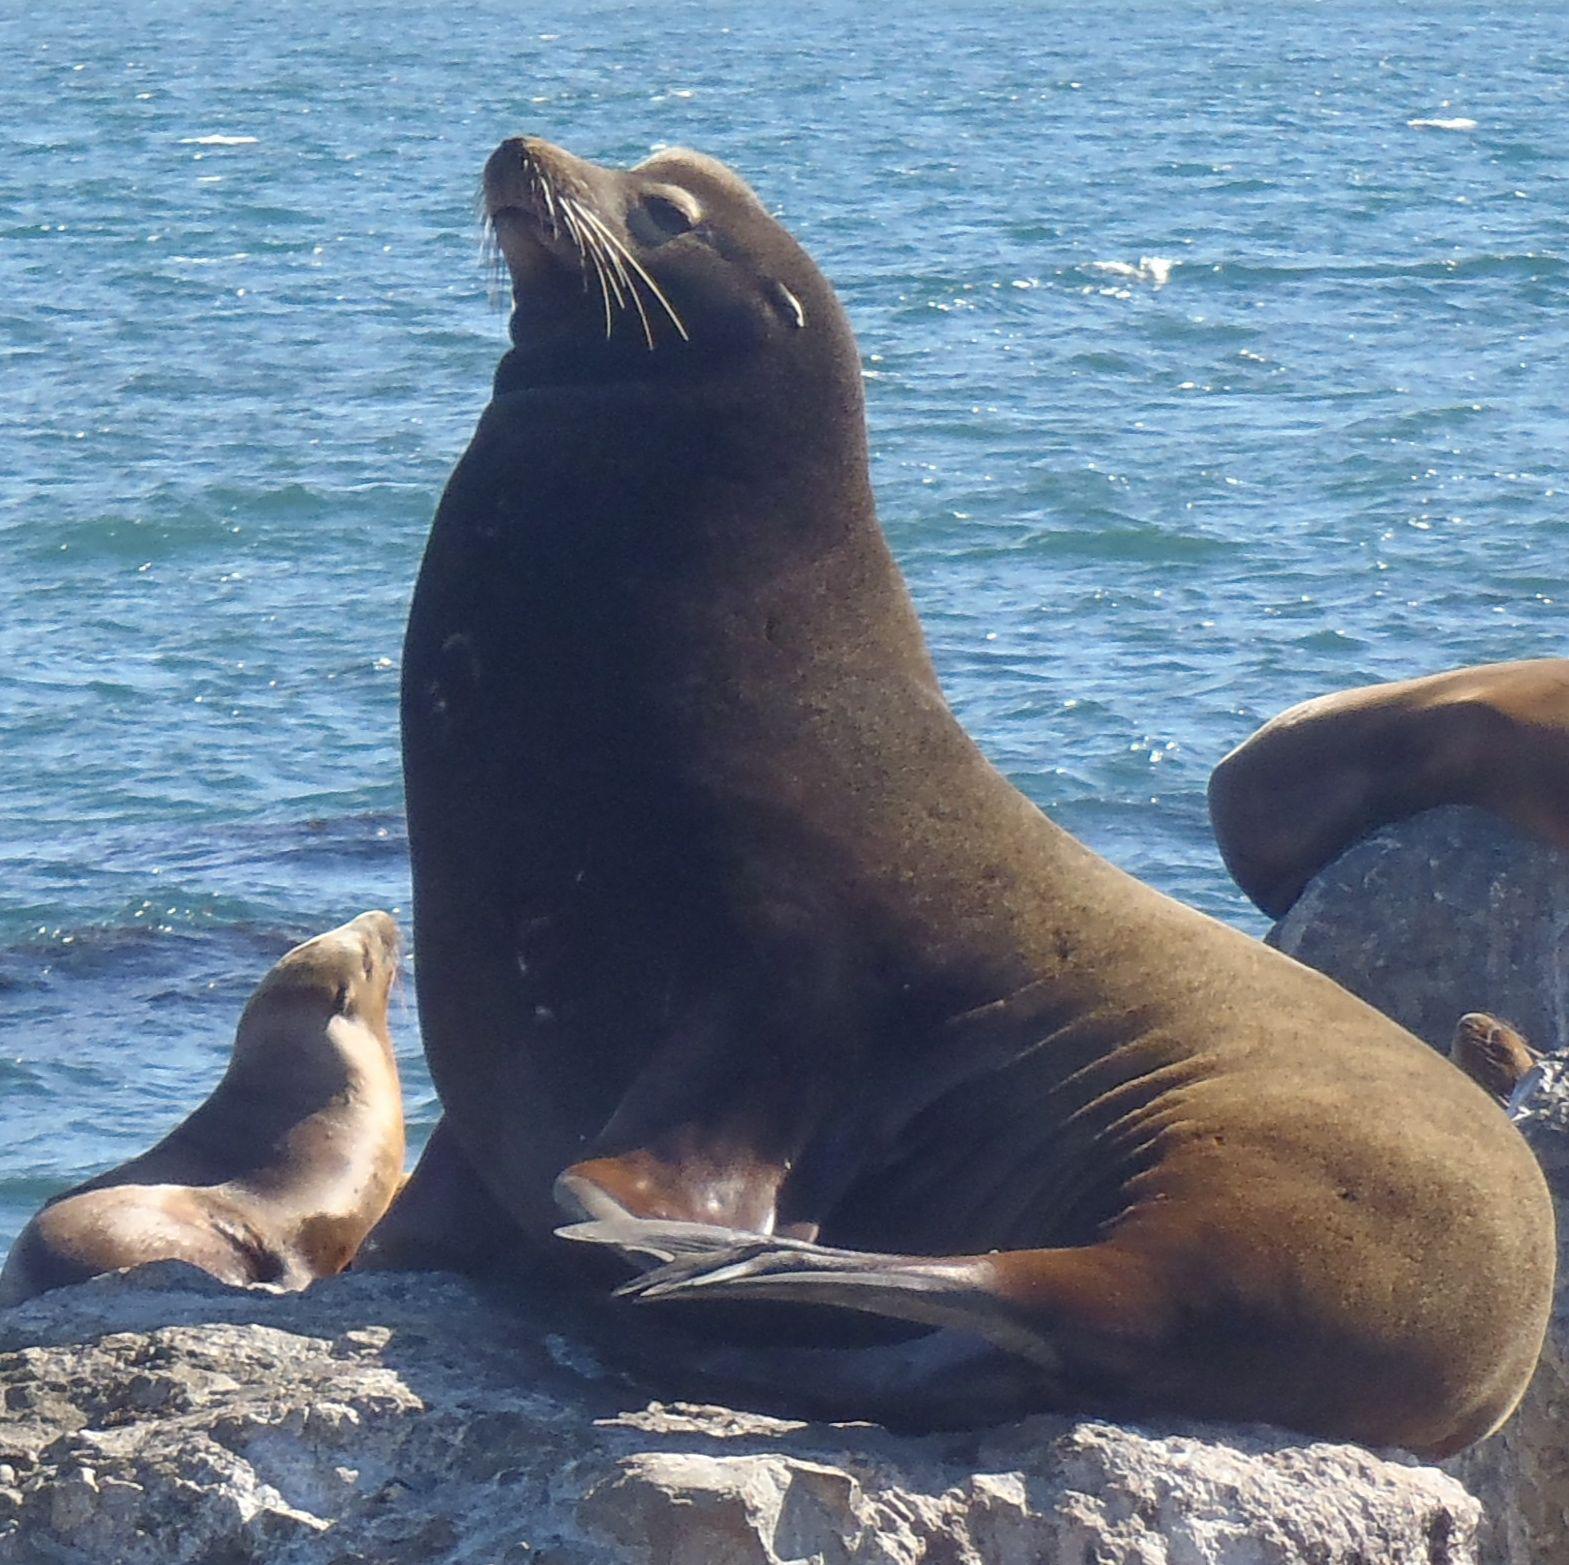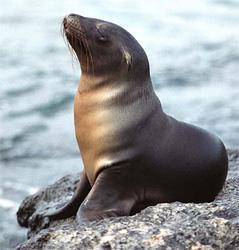The first image is the image on the left, the second image is the image on the right. For the images shown, is this caption "The right image includes a sleek gray seal with raised right-turned head and body turned to the camera, perched on a large rock in front of blue-green water." true? Answer yes or no. No. The first image is the image on the left, the second image is the image on the right. Analyze the images presented: Is the assertion "The right image contains two seals." valid? Answer yes or no. No. 